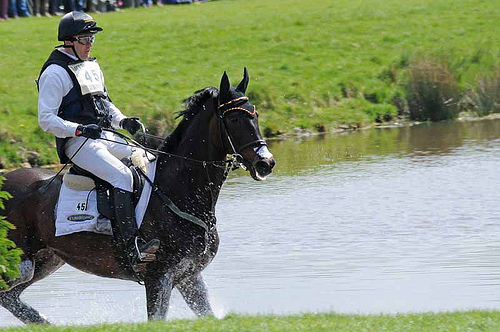Do the gloves and the boots have the sharegpt4v/same color? Yes, the gloves and the boots are the sharegpt4v/same color. 